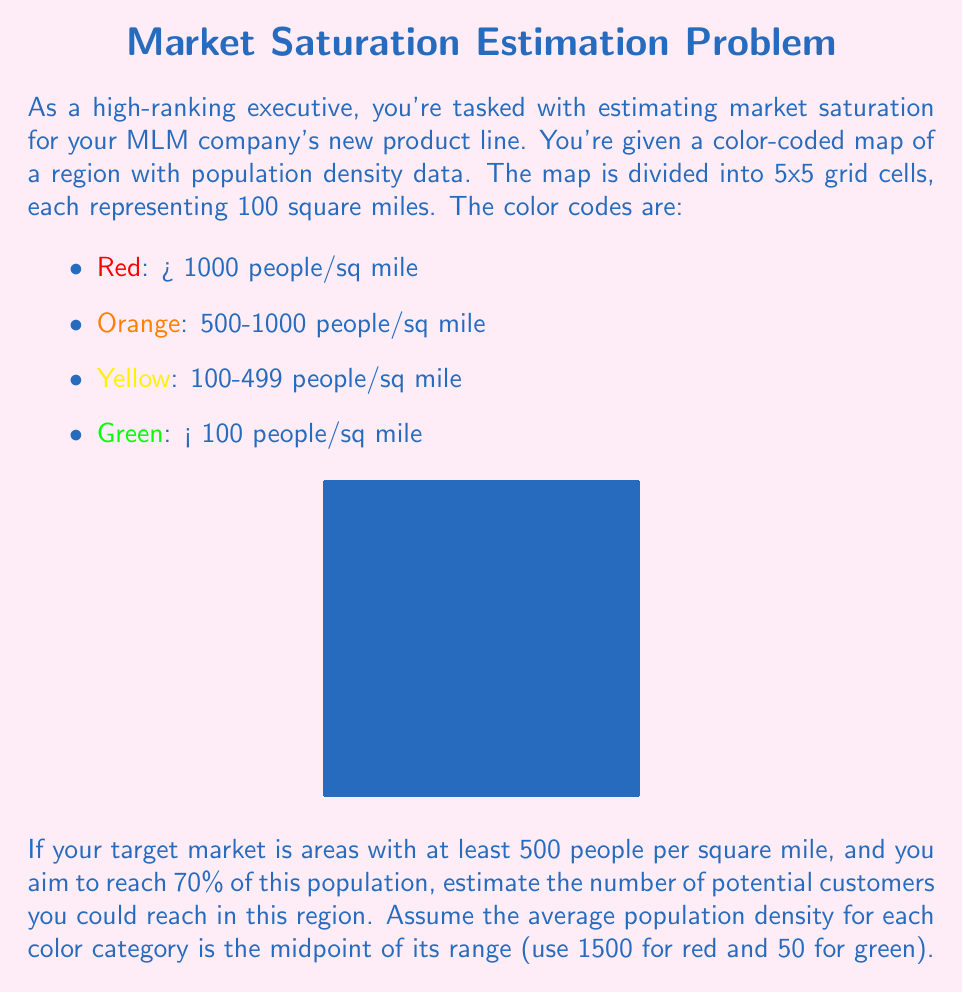Help me with this question. Let's approach this step-by-step:

1) First, we need to count the number of cells for each color:
   Red: 3 cells
   Orange: 5 cells
   Yellow: 8 cells
   Green: 9 cells

2) Calculate the average population density for each color:
   Red: 1500 people/sq mile
   Orange: (500 + 1000) / 2 = 750 people/sq mile
   Yellow: (100 + 499) / 2 = 299.5 people/sq mile
   Green: 50 people/sq mile

3) Calculate the total population in each color category:
   Red: 3 * 100 * 1500 = 450,000
   Orange: 5 * 100 * 750 = 375,000
   Total in target market (Red + Orange) = 825,000

4) Calculate 70% of the target market:
   $$0.7 * 825,000 = 577,500$$

Therefore, you could potentially reach 577,500 customers in this region.
Answer: 577,500 customers 